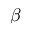<formula> <loc_0><loc_0><loc_500><loc_500>\beta</formula> 